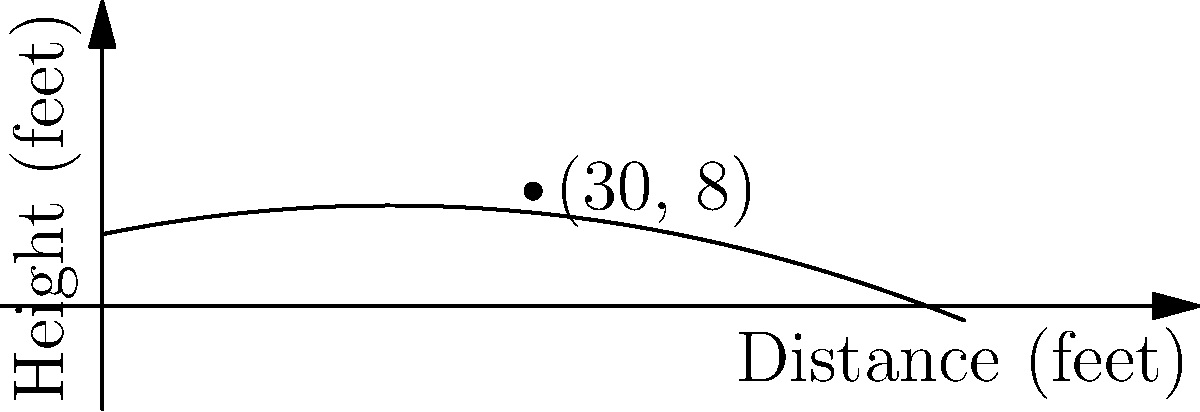As a former professional baseball player, you're analyzing the trajectory of a curveball pitch. The path of the ball can be modeled by the polynomial function $h(d) = -0.005d^2 + 0.2d + 5$, where $h$ is the height of the ball in feet and $d$ is the horizontal distance from the pitcher in feet. If the ball passes over home plate at a distance of 60 feet from the pitcher, what is the maximum height reached by the ball during its flight? To find the maximum height of the ball's trajectory, we need to follow these steps:

1) The function given is $h(d) = -0.005d^2 + 0.2d + 5$, which is a quadratic function.

2) For a quadratic function in the form $f(x) = ax^2 + bx + c$, the x-coordinate of the vertex is given by $x = -\frac{b}{2a}$.

3) In our case, $a = -0.005$ and $b = 0.2$. Let's substitute these values:

   $d = -\frac{0.2}{2(-0.005)} = -\frac{0.2}{-0.01} = 20$

4) This means the ball reaches its maximum height when it's 20 feet away from the pitcher.

5) To find the maximum height, we need to calculate $h(20)$:

   $h(20) = -0.005(20)^2 + 0.2(20) + 5$
   $= -0.005(400) + 4 + 5$
   $= -2 + 4 + 5$
   $= 7$

Therefore, the maximum height reached by the ball is 7 feet.
Answer: 7 feet 